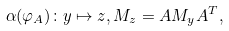Convert formula to latex. <formula><loc_0><loc_0><loc_500><loc_500>\alpha ( \varphi _ { A } ) \colon y \mapsto z , M _ { z } = A M _ { y } A ^ { T } ,</formula> 